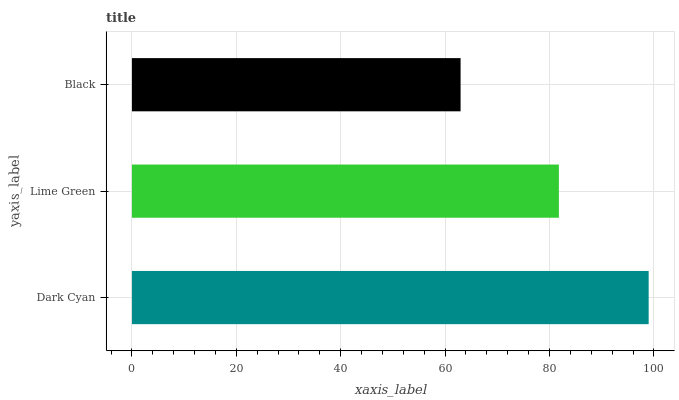Is Black the minimum?
Answer yes or no. Yes. Is Dark Cyan the maximum?
Answer yes or no. Yes. Is Lime Green the minimum?
Answer yes or no. No. Is Lime Green the maximum?
Answer yes or no. No. Is Dark Cyan greater than Lime Green?
Answer yes or no. Yes. Is Lime Green less than Dark Cyan?
Answer yes or no. Yes. Is Lime Green greater than Dark Cyan?
Answer yes or no. No. Is Dark Cyan less than Lime Green?
Answer yes or no. No. Is Lime Green the high median?
Answer yes or no. Yes. Is Lime Green the low median?
Answer yes or no. Yes. Is Black the high median?
Answer yes or no. No. Is Black the low median?
Answer yes or no. No. 